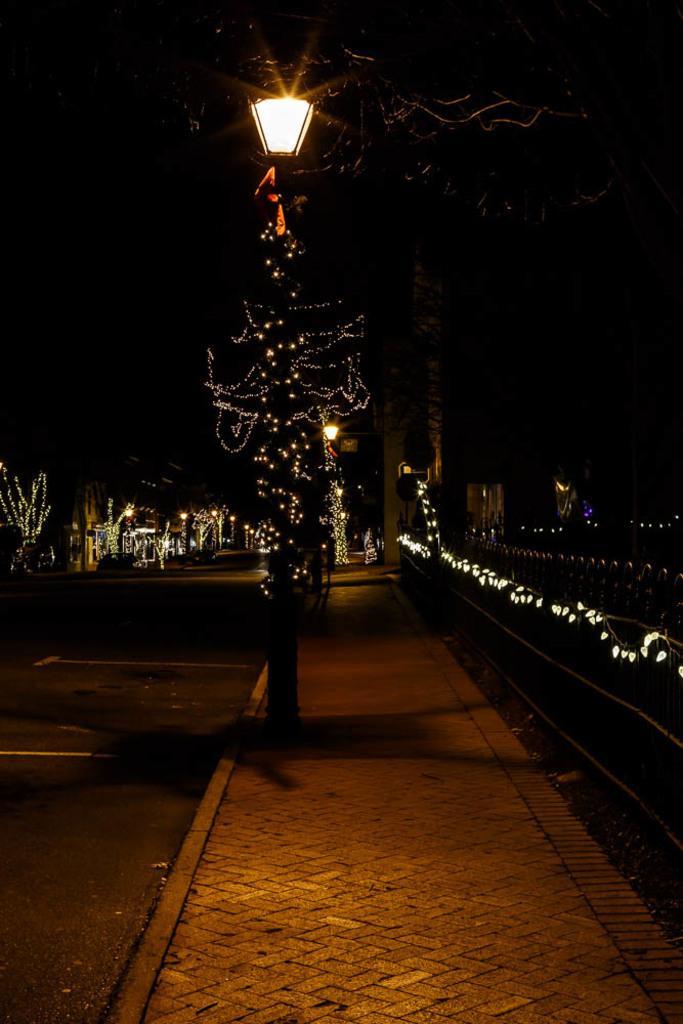Please provide a concise description of this image. In this image there are road and footpath. There is a fencing on the right side. There are trees with lights. 